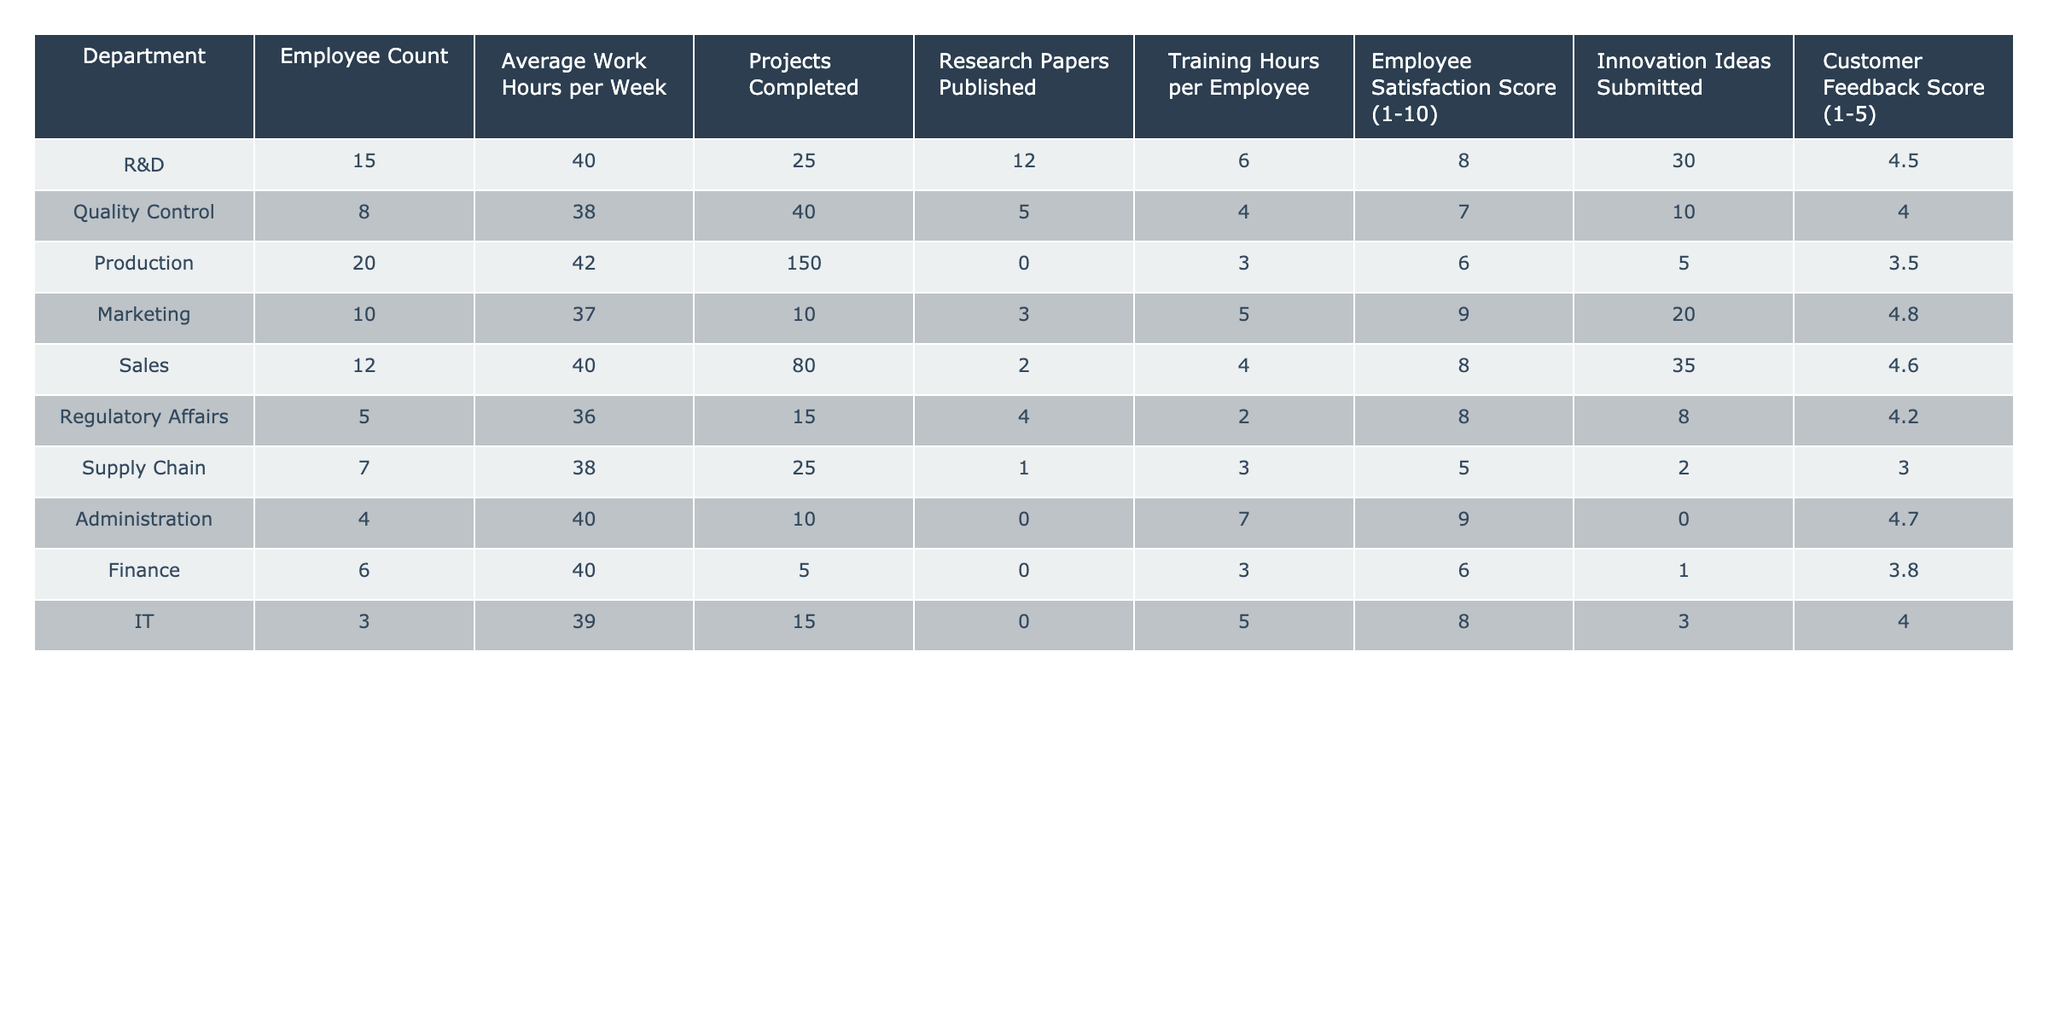What department has the highest employee count? The employee count for each department is listed in the table. Looking at the counts, Production has 20 employees, which is the highest compared to the other departments.
Answer: Production What is the average work hours per week for the R&D department? The average work hours for the R&D department is explicitly provided in the table as 40 hours.
Answer: 40 hours Which department has the lowest customer feedback score? By examining the customer feedback score for all departments in the table, Supply Chain has the lowest score of 3.0.
Answer: Supply Chain What is the total number of projects completed across all departments? To find the total, sum the projects completed for each department: 25 + 40 + 150 + 10 + 80 + 15 + 25 + 10 + 5 + 15 = 360.
Answer: 360 Is the average employee satisfaction score for Marketing greater than 8? The employee satisfaction score for Marketing is 9 according to the table, which is greater than 8.
Answer: Yes Which department has the highest number of innovation ideas submitted? The table shows that the R&D department has submitted the most innovation ideas, totaling 30.
Answer: R&D What is the average training hours per employee across all departments? Calculate the total training hours by summing them up: 6 + 4 + 3 + 5 + 4 + 2 + 3 + 7 + 3 + 5 = 43. Divide by the total employee count (15 + 8 + 20 + 10 + 12 + 5 + 7 + 4 + 6 + 3 = 90), resulting in an average of 43/90 ≈ 0.48 hours per employee.
Answer: 0.48 hours Which department has the most research papers published relative to its employee count? Calculate the research papers per employee for each department: R&D (12/15=0.8), Quality Control (5/8=0.625), Production (0), Marketing (3/10=0.3), Sales (2/12=0.167), Regulatory Affairs (4/5=0.8), Supply Chain (1/7=0.143), Administration (0), Finance (0), and IT (0). R&D and Regulatory Affairs both have 0.8.
Answer: R&D and Regulatory Affairs What is the difference in average work hours per week between the Production and Quality Control departments? From the table, Production has an average of 42 hours and Quality Control has 38 hours. The difference is 42 - 38 = 4 hours.
Answer: 4 hours Are there more employees in the Sales department than in the Administration department? The table indicates that Sales has 12 employees and Administration has 4. Since 12 is greater than 4, the statement is true.
Answer: Yes 